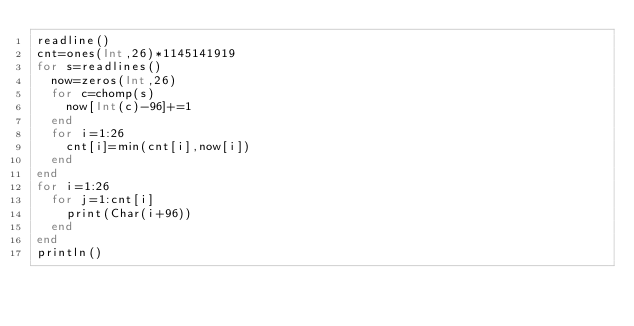<code> <loc_0><loc_0><loc_500><loc_500><_Julia_>readline()
cnt=ones(Int,26)*1145141919
for s=readlines()
  now=zeros(Int,26)
  for c=chomp(s)
    now[Int(c)-96]+=1
  end
  for i=1:26
    cnt[i]=min(cnt[i],now[i])
  end
end
for i=1:26
  for j=1:cnt[i]
    print(Char(i+96))
  end
end
println()</code> 